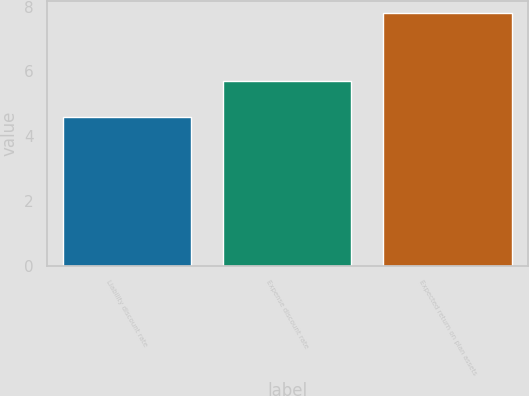Convert chart to OTSL. <chart><loc_0><loc_0><loc_500><loc_500><bar_chart><fcel>Liability discount rate<fcel>Expense discount rate<fcel>Expected return on plan assets<nl><fcel>4.6<fcel>5.7<fcel>7.8<nl></chart> 